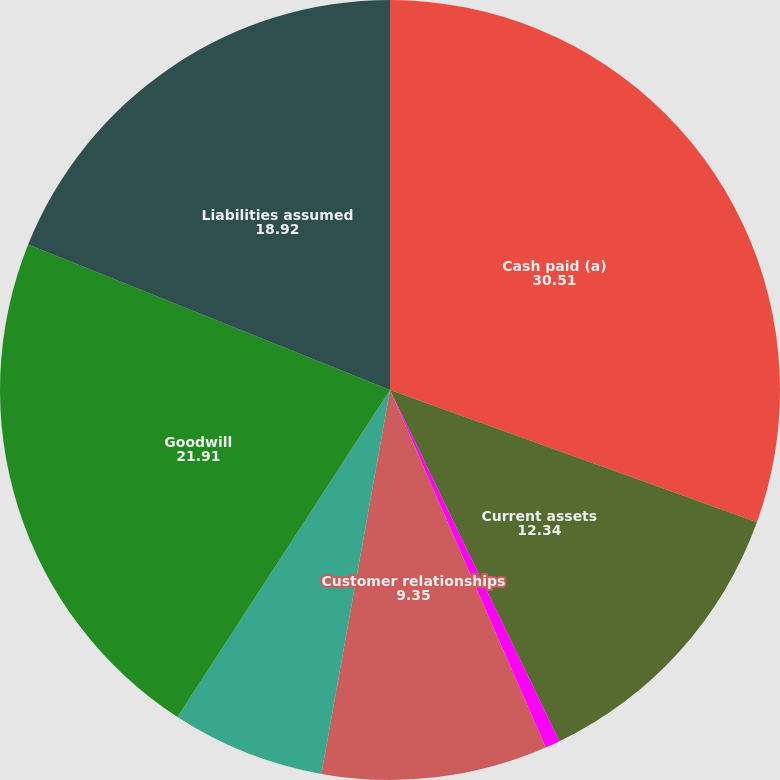Convert chart. <chart><loc_0><loc_0><loc_500><loc_500><pie_chart><fcel>Cash paid (a)<fcel>Current assets<fcel>Property plant and equipment<fcel>Customer relationships<fcel>Product technology<fcel>Goodwill<fcel>Liabilities assumed<nl><fcel>30.51%<fcel>12.34%<fcel>0.62%<fcel>9.35%<fcel>6.36%<fcel>21.91%<fcel>18.92%<nl></chart> 